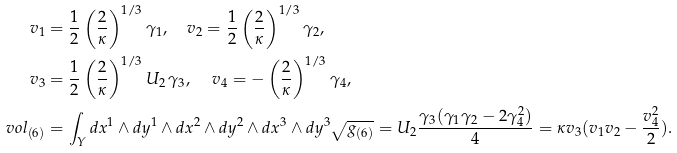<formula> <loc_0><loc_0><loc_500><loc_500>v _ { 1 } & = \frac { 1 } { 2 } \left ( \frac { 2 } { \kappa } \right ) ^ { 1 / 3 } \gamma _ { 1 } , \quad v _ { 2 } = \frac { 1 } { 2 } \left ( \frac { 2 } { \kappa } \right ) ^ { 1 / 3 } \gamma _ { 2 } , \\ v _ { 3 } & = \frac { 1 } { 2 } \left ( \frac { 2 } { \kappa } \right ) ^ { 1 / 3 } U _ { 2 } \, \gamma _ { 3 } , \quad \, v _ { 4 } = - \left ( \frac { 2 } { \kappa } \right ) ^ { 1 / 3 } \gamma _ { 4 } , \\ v o l _ { ( 6 ) } & = \int _ { Y } d x ^ { 1 } \wedge d y ^ { 1 } \wedge d x ^ { 2 } \wedge d y ^ { 2 } \wedge d x ^ { 3 } \wedge d y ^ { 3 } \sqrt { g _ { ( 6 ) } } = U _ { 2 } \frac { \gamma _ { 3 } ( \gamma _ { 1 } \gamma _ { 2 } - 2 \gamma _ { 4 } ^ { 2 } ) } { 4 } = \kappa v _ { 3 } ( v _ { 1 } v _ { 2 } - \frac { v _ { 4 } ^ { 2 } } { 2 } ) .</formula> 